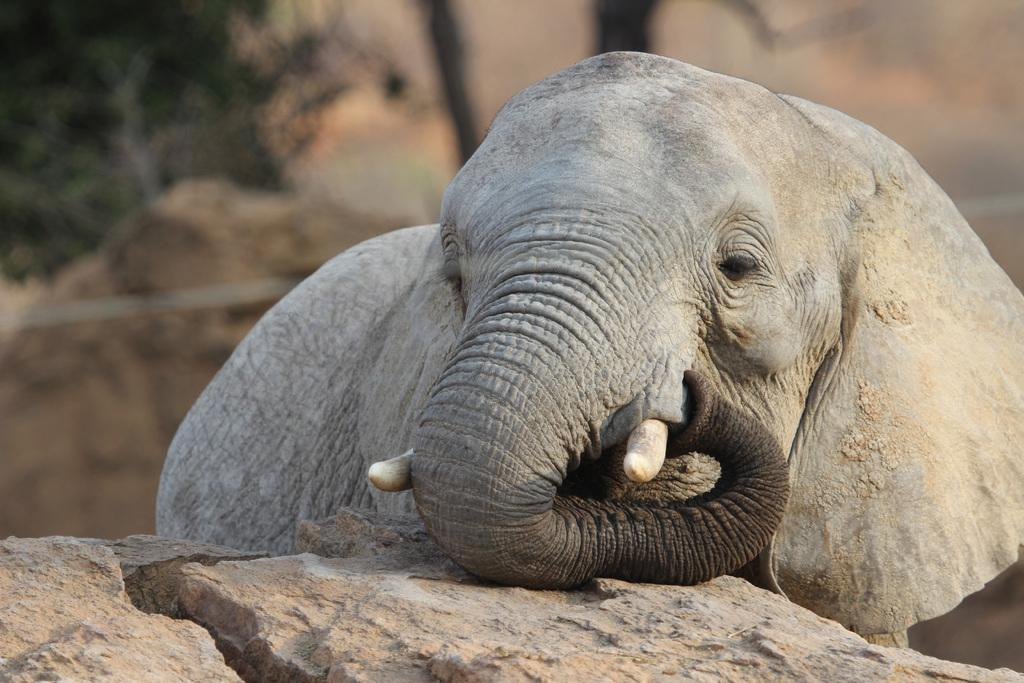What animal can be seen on the ground in the image? There is an elephant on the ground in the image. Can you describe the background details be clearly seen in the image? No, the background of the image is blurred. How many attempts did the elephant make to pick up the twig in the image? There is no twig present in the image, and therefore no such activity can be observed. 